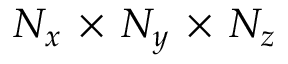Convert formula to latex. <formula><loc_0><loc_0><loc_500><loc_500>N _ { x } \, \times \, N _ { y } \, \times \, N _ { z }</formula> 